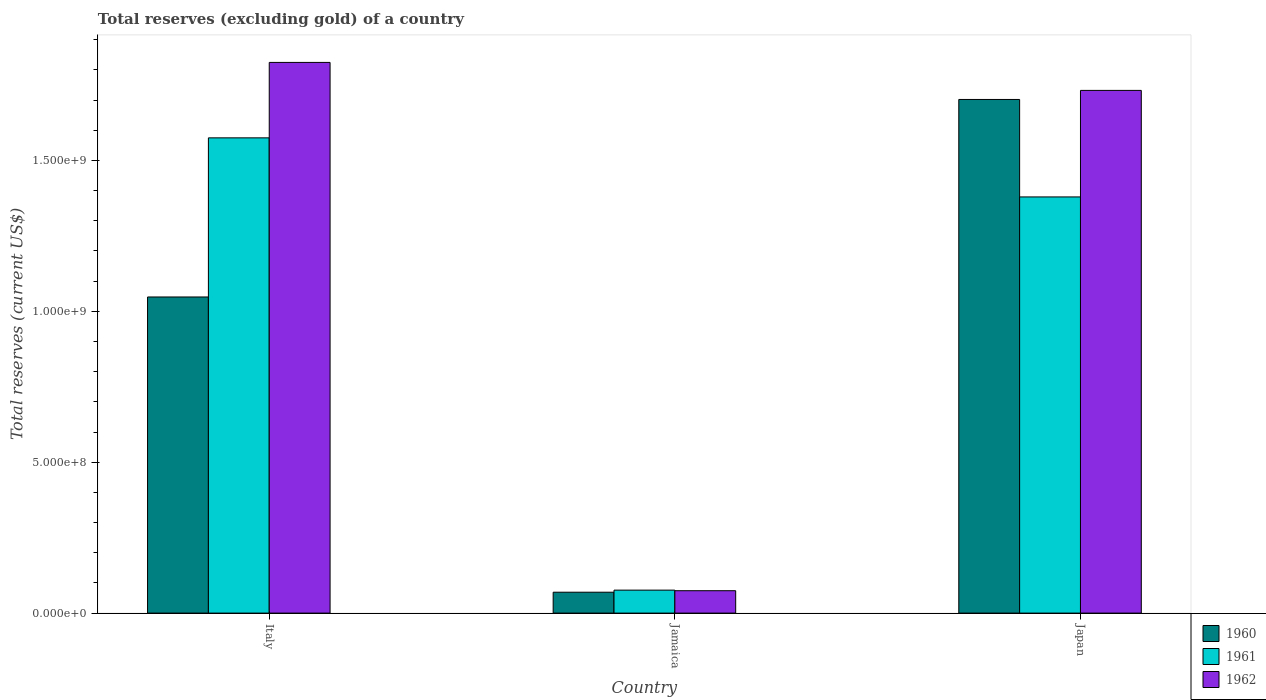Are the number of bars per tick equal to the number of legend labels?
Keep it short and to the point. Yes. Are the number of bars on each tick of the X-axis equal?
Keep it short and to the point. Yes. How many bars are there on the 1st tick from the left?
Provide a short and direct response. 3. How many bars are there on the 1st tick from the right?
Give a very brief answer. 3. What is the total reserves (excluding gold) in 1962 in Japan?
Offer a very short reply. 1.73e+09. Across all countries, what is the maximum total reserves (excluding gold) in 1961?
Offer a very short reply. 1.57e+09. Across all countries, what is the minimum total reserves (excluding gold) in 1960?
Make the answer very short. 6.92e+07. In which country was the total reserves (excluding gold) in 1962 minimum?
Your answer should be very brief. Jamaica. What is the total total reserves (excluding gold) in 1962 in the graph?
Give a very brief answer. 3.63e+09. What is the difference between the total reserves (excluding gold) in 1962 in Jamaica and that in Japan?
Your response must be concise. -1.66e+09. What is the difference between the total reserves (excluding gold) in 1962 in Jamaica and the total reserves (excluding gold) in 1961 in Japan?
Make the answer very short. -1.30e+09. What is the average total reserves (excluding gold) in 1960 per country?
Offer a terse response. 9.40e+08. What is the difference between the total reserves (excluding gold) of/in 1962 and total reserves (excluding gold) of/in 1960 in Jamaica?
Offer a very short reply. 5.00e+06. In how many countries, is the total reserves (excluding gold) in 1961 greater than 1000000000 US$?
Ensure brevity in your answer.  2. What is the ratio of the total reserves (excluding gold) in 1961 in Italy to that in Japan?
Give a very brief answer. 1.14. Is the difference between the total reserves (excluding gold) in 1962 in Italy and Japan greater than the difference between the total reserves (excluding gold) in 1960 in Italy and Japan?
Your answer should be very brief. Yes. What is the difference between the highest and the second highest total reserves (excluding gold) in 1961?
Provide a short and direct response. 1.30e+09. What is the difference between the highest and the lowest total reserves (excluding gold) in 1960?
Your answer should be compact. 1.63e+09. In how many countries, is the total reserves (excluding gold) in 1961 greater than the average total reserves (excluding gold) in 1961 taken over all countries?
Keep it short and to the point. 2. What does the 1st bar from the left in Japan represents?
Make the answer very short. 1960. Is it the case that in every country, the sum of the total reserves (excluding gold) in 1961 and total reserves (excluding gold) in 1962 is greater than the total reserves (excluding gold) in 1960?
Offer a terse response. Yes. Are all the bars in the graph horizontal?
Make the answer very short. No. How many countries are there in the graph?
Keep it short and to the point. 3. What is the difference between two consecutive major ticks on the Y-axis?
Give a very brief answer. 5.00e+08. Are the values on the major ticks of Y-axis written in scientific E-notation?
Your answer should be compact. Yes. Where does the legend appear in the graph?
Keep it short and to the point. Bottom right. How are the legend labels stacked?
Provide a short and direct response. Vertical. What is the title of the graph?
Provide a succinct answer. Total reserves (excluding gold) of a country. What is the label or title of the Y-axis?
Provide a succinct answer. Total reserves (current US$). What is the Total reserves (current US$) in 1960 in Italy?
Give a very brief answer. 1.05e+09. What is the Total reserves (current US$) of 1961 in Italy?
Provide a short and direct response. 1.57e+09. What is the Total reserves (current US$) in 1962 in Italy?
Ensure brevity in your answer.  1.82e+09. What is the Total reserves (current US$) in 1960 in Jamaica?
Give a very brief answer. 6.92e+07. What is the Total reserves (current US$) in 1961 in Jamaica?
Keep it short and to the point. 7.61e+07. What is the Total reserves (current US$) of 1962 in Jamaica?
Offer a terse response. 7.42e+07. What is the Total reserves (current US$) in 1960 in Japan?
Offer a very short reply. 1.70e+09. What is the Total reserves (current US$) in 1961 in Japan?
Make the answer very short. 1.38e+09. What is the Total reserves (current US$) of 1962 in Japan?
Offer a terse response. 1.73e+09. Across all countries, what is the maximum Total reserves (current US$) of 1960?
Ensure brevity in your answer.  1.70e+09. Across all countries, what is the maximum Total reserves (current US$) in 1961?
Ensure brevity in your answer.  1.57e+09. Across all countries, what is the maximum Total reserves (current US$) of 1962?
Keep it short and to the point. 1.82e+09. Across all countries, what is the minimum Total reserves (current US$) of 1960?
Your answer should be compact. 6.92e+07. Across all countries, what is the minimum Total reserves (current US$) in 1961?
Give a very brief answer. 7.61e+07. Across all countries, what is the minimum Total reserves (current US$) in 1962?
Offer a terse response. 7.42e+07. What is the total Total reserves (current US$) of 1960 in the graph?
Provide a short and direct response. 2.82e+09. What is the total Total reserves (current US$) in 1961 in the graph?
Ensure brevity in your answer.  3.03e+09. What is the total Total reserves (current US$) of 1962 in the graph?
Make the answer very short. 3.63e+09. What is the difference between the Total reserves (current US$) of 1960 in Italy and that in Jamaica?
Provide a short and direct response. 9.78e+08. What is the difference between the Total reserves (current US$) of 1961 in Italy and that in Jamaica?
Provide a short and direct response. 1.50e+09. What is the difference between the Total reserves (current US$) of 1962 in Italy and that in Jamaica?
Your answer should be very brief. 1.75e+09. What is the difference between the Total reserves (current US$) in 1960 in Italy and that in Japan?
Offer a terse response. -6.55e+08. What is the difference between the Total reserves (current US$) of 1961 in Italy and that in Japan?
Give a very brief answer. 1.96e+08. What is the difference between the Total reserves (current US$) of 1962 in Italy and that in Japan?
Provide a succinct answer. 9.27e+07. What is the difference between the Total reserves (current US$) in 1960 in Jamaica and that in Japan?
Provide a short and direct response. -1.63e+09. What is the difference between the Total reserves (current US$) of 1961 in Jamaica and that in Japan?
Make the answer very short. -1.30e+09. What is the difference between the Total reserves (current US$) in 1962 in Jamaica and that in Japan?
Provide a short and direct response. -1.66e+09. What is the difference between the Total reserves (current US$) in 1960 in Italy and the Total reserves (current US$) in 1961 in Jamaica?
Your answer should be very brief. 9.71e+08. What is the difference between the Total reserves (current US$) in 1960 in Italy and the Total reserves (current US$) in 1962 in Jamaica?
Your response must be concise. 9.73e+08. What is the difference between the Total reserves (current US$) of 1961 in Italy and the Total reserves (current US$) of 1962 in Jamaica?
Provide a succinct answer. 1.50e+09. What is the difference between the Total reserves (current US$) of 1960 in Italy and the Total reserves (current US$) of 1961 in Japan?
Provide a short and direct response. -3.32e+08. What is the difference between the Total reserves (current US$) of 1960 in Italy and the Total reserves (current US$) of 1962 in Japan?
Offer a very short reply. -6.85e+08. What is the difference between the Total reserves (current US$) in 1961 in Italy and the Total reserves (current US$) in 1962 in Japan?
Ensure brevity in your answer.  -1.57e+08. What is the difference between the Total reserves (current US$) in 1960 in Jamaica and the Total reserves (current US$) in 1961 in Japan?
Keep it short and to the point. -1.31e+09. What is the difference between the Total reserves (current US$) in 1960 in Jamaica and the Total reserves (current US$) in 1962 in Japan?
Your answer should be very brief. -1.66e+09. What is the difference between the Total reserves (current US$) in 1961 in Jamaica and the Total reserves (current US$) in 1962 in Japan?
Give a very brief answer. -1.66e+09. What is the average Total reserves (current US$) of 1960 per country?
Your response must be concise. 9.40e+08. What is the average Total reserves (current US$) in 1961 per country?
Provide a short and direct response. 1.01e+09. What is the average Total reserves (current US$) in 1962 per country?
Make the answer very short. 1.21e+09. What is the difference between the Total reserves (current US$) of 1960 and Total reserves (current US$) of 1961 in Italy?
Ensure brevity in your answer.  -5.27e+08. What is the difference between the Total reserves (current US$) of 1960 and Total reserves (current US$) of 1962 in Italy?
Your response must be concise. -7.77e+08. What is the difference between the Total reserves (current US$) in 1961 and Total reserves (current US$) in 1962 in Italy?
Make the answer very short. -2.50e+08. What is the difference between the Total reserves (current US$) in 1960 and Total reserves (current US$) in 1961 in Jamaica?
Offer a very short reply. -6.90e+06. What is the difference between the Total reserves (current US$) of 1960 and Total reserves (current US$) of 1962 in Jamaica?
Offer a terse response. -5.00e+06. What is the difference between the Total reserves (current US$) in 1961 and Total reserves (current US$) in 1962 in Jamaica?
Provide a succinct answer. 1.90e+06. What is the difference between the Total reserves (current US$) of 1960 and Total reserves (current US$) of 1961 in Japan?
Your answer should be very brief. 3.23e+08. What is the difference between the Total reserves (current US$) in 1960 and Total reserves (current US$) in 1962 in Japan?
Your answer should be compact. -3.00e+07. What is the difference between the Total reserves (current US$) in 1961 and Total reserves (current US$) in 1962 in Japan?
Provide a short and direct response. -3.53e+08. What is the ratio of the Total reserves (current US$) of 1960 in Italy to that in Jamaica?
Your response must be concise. 15.14. What is the ratio of the Total reserves (current US$) of 1961 in Italy to that in Jamaica?
Keep it short and to the point. 20.69. What is the ratio of the Total reserves (current US$) of 1962 in Italy to that in Jamaica?
Keep it short and to the point. 24.59. What is the ratio of the Total reserves (current US$) of 1960 in Italy to that in Japan?
Provide a short and direct response. 0.62. What is the ratio of the Total reserves (current US$) in 1961 in Italy to that in Japan?
Provide a succinct answer. 1.14. What is the ratio of the Total reserves (current US$) in 1962 in Italy to that in Japan?
Provide a succinct answer. 1.05. What is the ratio of the Total reserves (current US$) in 1960 in Jamaica to that in Japan?
Offer a terse response. 0.04. What is the ratio of the Total reserves (current US$) of 1961 in Jamaica to that in Japan?
Give a very brief answer. 0.06. What is the ratio of the Total reserves (current US$) in 1962 in Jamaica to that in Japan?
Make the answer very short. 0.04. What is the difference between the highest and the second highest Total reserves (current US$) of 1960?
Make the answer very short. 6.55e+08. What is the difference between the highest and the second highest Total reserves (current US$) in 1961?
Ensure brevity in your answer.  1.96e+08. What is the difference between the highest and the second highest Total reserves (current US$) in 1962?
Your answer should be very brief. 9.27e+07. What is the difference between the highest and the lowest Total reserves (current US$) in 1960?
Ensure brevity in your answer.  1.63e+09. What is the difference between the highest and the lowest Total reserves (current US$) in 1961?
Make the answer very short. 1.50e+09. What is the difference between the highest and the lowest Total reserves (current US$) of 1962?
Offer a very short reply. 1.75e+09. 